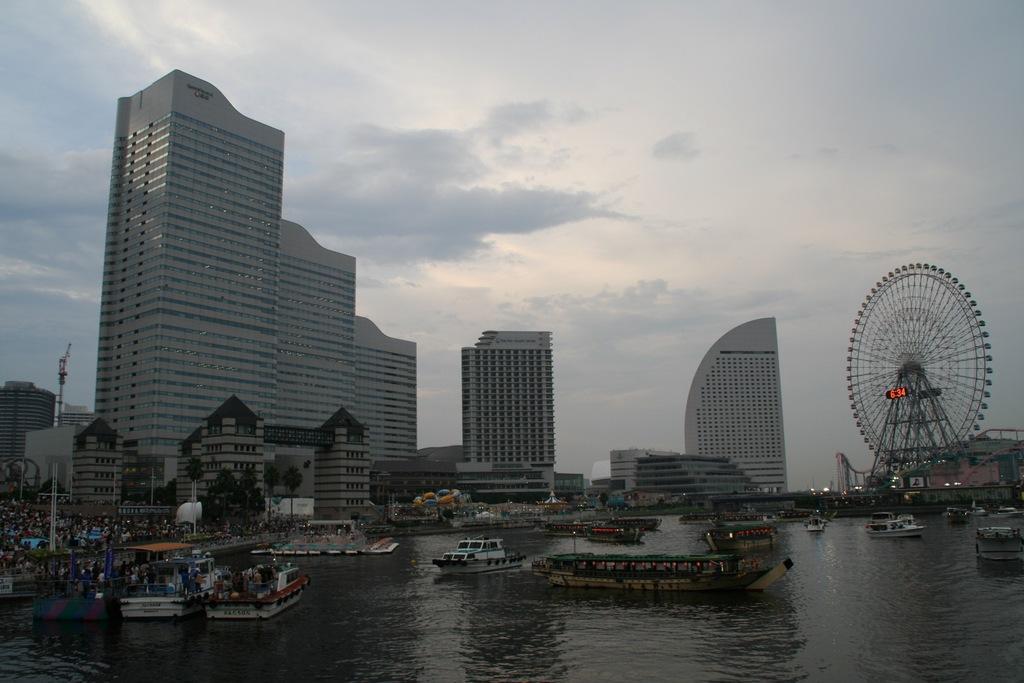Can you describe this image briefly? In this image there are many ships and boats in the river. In the background of the image there are many buildings, stalls, trees and sky. 